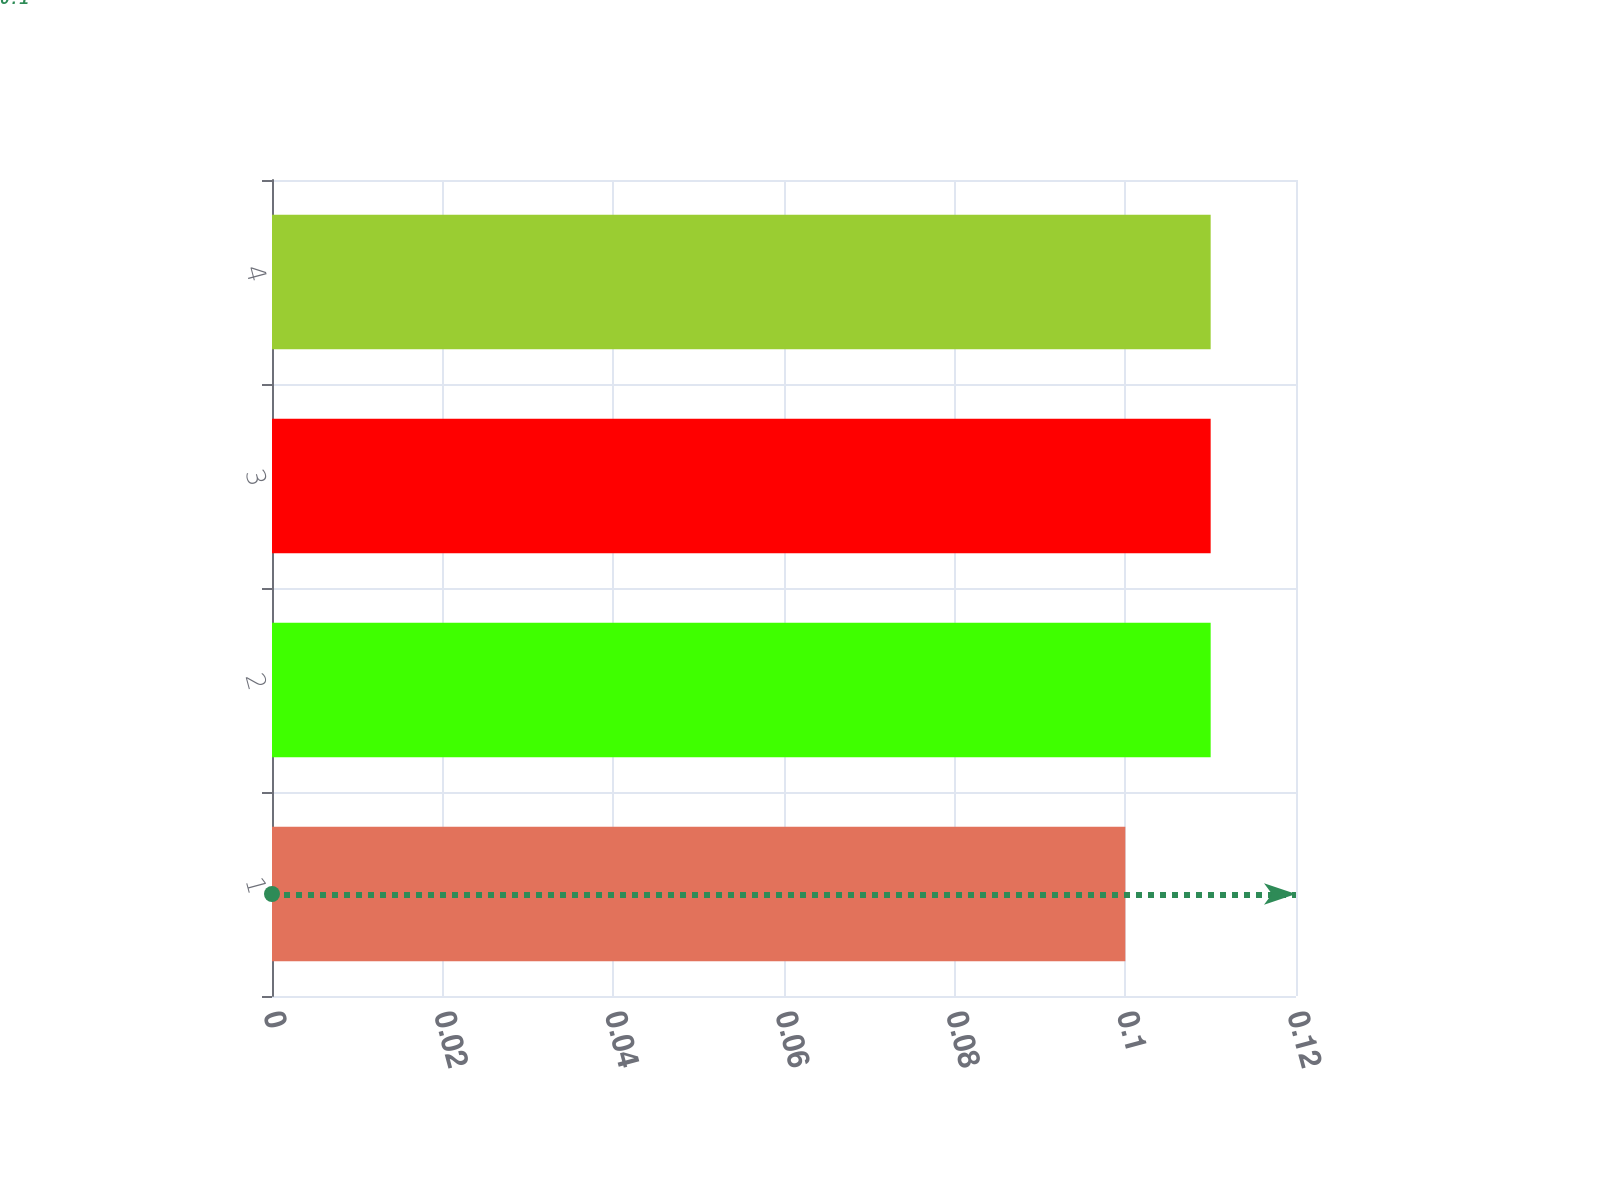Convert chart to OTSL. <chart><loc_0><loc_0><loc_500><loc_500><bar_chart><fcel>1<fcel>2<fcel>3<fcel>4<nl><fcel>0.1<fcel>0.11<fcel>0.11<fcel>0.11<nl></chart> 